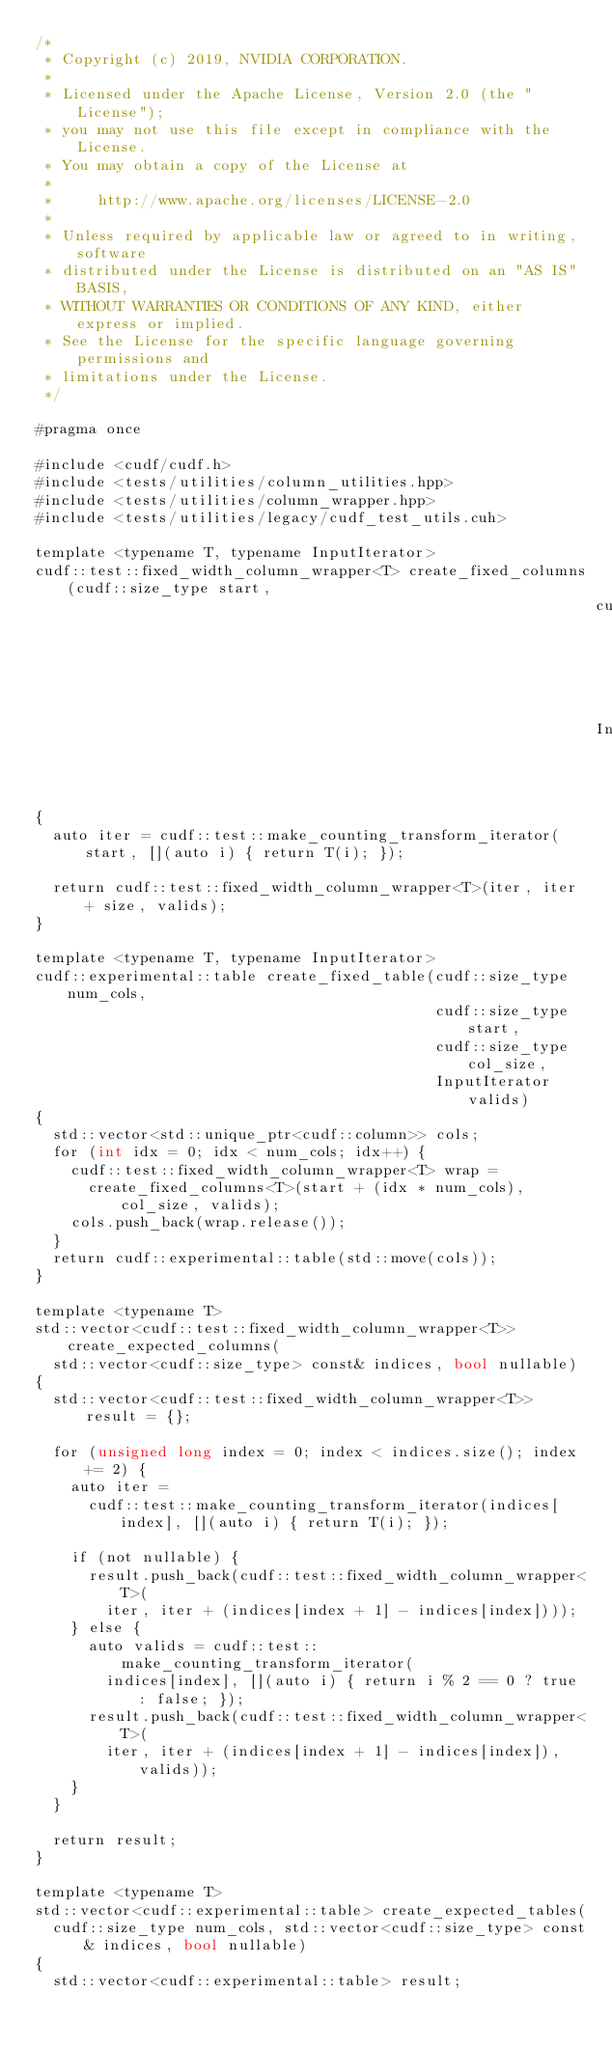Convert code to text. <code><loc_0><loc_0><loc_500><loc_500><_Cuda_>/*
 * Copyright (c) 2019, NVIDIA CORPORATION.
 *
 * Licensed under the Apache License, Version 2.0 (the "License");
 * you may not use this file except in compliance with the License.
 * You may obtain a copy of the License at
 *
 *     http://www.apache.org/licenses/LICENSE-2.0
 *
 * Unless required by applicable law or agreed to in writing, software
 * distributed under the License is distributed on an "AS IS" BASIS,
 * WITHOUT WARRANTIES OR CONDITIONS OF ANY KIND, either express or implied.
 * See the License for the specific language governing permissions and
 * limitations under the License.
 */

#pragma once

#include <cudf/cudf.h>
#include <tests/utilities/column_utilities.hpp>
#include <tests/utilities/column_wrapper.hpp>
#include <tests/utilities/legacy/cudf_test_utils.cuh>

template <typename T, typename InputIterator>
cudf::test::fixed_width_column_wrapper<T> create_fixed_columns(cudf::size_type start,
                                                               cudf::size_type size,
                                                               InputIterator valids)
{
  auto iter = cudf::test::make_counting_transform_iterator(start, [](auto i) { return T(i); });

  return cudf::test::fixed_width_column_wrapper<T>(iter, iter + size, valids);
}

template <typename T, typename InputIterator>
cudf::experimental::table create_fixed_table(cudf::size_type num_cols,
                                             cudf::size_type start,
                                             cudf::size_type col_size,
                                             InputIterator valids)
{
  std::vector<std::unique_ptr<cudf::column>> cols;
  for (int idx = 0; idx < num_cols; idx++) {
    cudf::test::fixed_width_column_wrapper<T> wrap =
      create_fixed_columns<T>(start + (idx * num_cols), col_size, valids);
    cols.push_back(wrap.release());
  }
  return cudf::experimental::table(std::move(cols));
}

template <typename T>
std::vector<cudf::test::fixed_width_column_wrapper<T>> create_expected_columns(
  std::vector<cudf::size_type> const& indices, bool nullable)
{
  std::vector<cudf::test::fixed_width_column_wrapper<T>> result = {};

  for (unsigned long index = 0; index < indices.size(); index += 2) {
    auto iter =
      cudf::test::make_counting_transform_iterator(indices[index], [](auto i) { return T(i); });

    if (not nullable) {
      result.push_back(cudf::test::fixed_width_column_wrapper<T>(
        iter, iter + (indices[index + 1] - indices[index])));
    } else {
      auto valids = cudf::test::make_counting_transform_iterator(
        indices[index], [](auto i) { return i % 2 == 0 ? true : false; });
      result.push_back(cudf::test::fixed_width_column_wrapper<T>(
        iter, iter + (indices[index + 1] - indices[index]), valids));
    }
  }

  return result;
}

template <typename T>
std::vector<cudf::experimental::table> create_expected_tables(
  cudf::size_type num_cols, std::vector<cudf::size_type> const& indices, bool nullable)
{
  std::vector<cudf::experimental::table> result;
</code> 